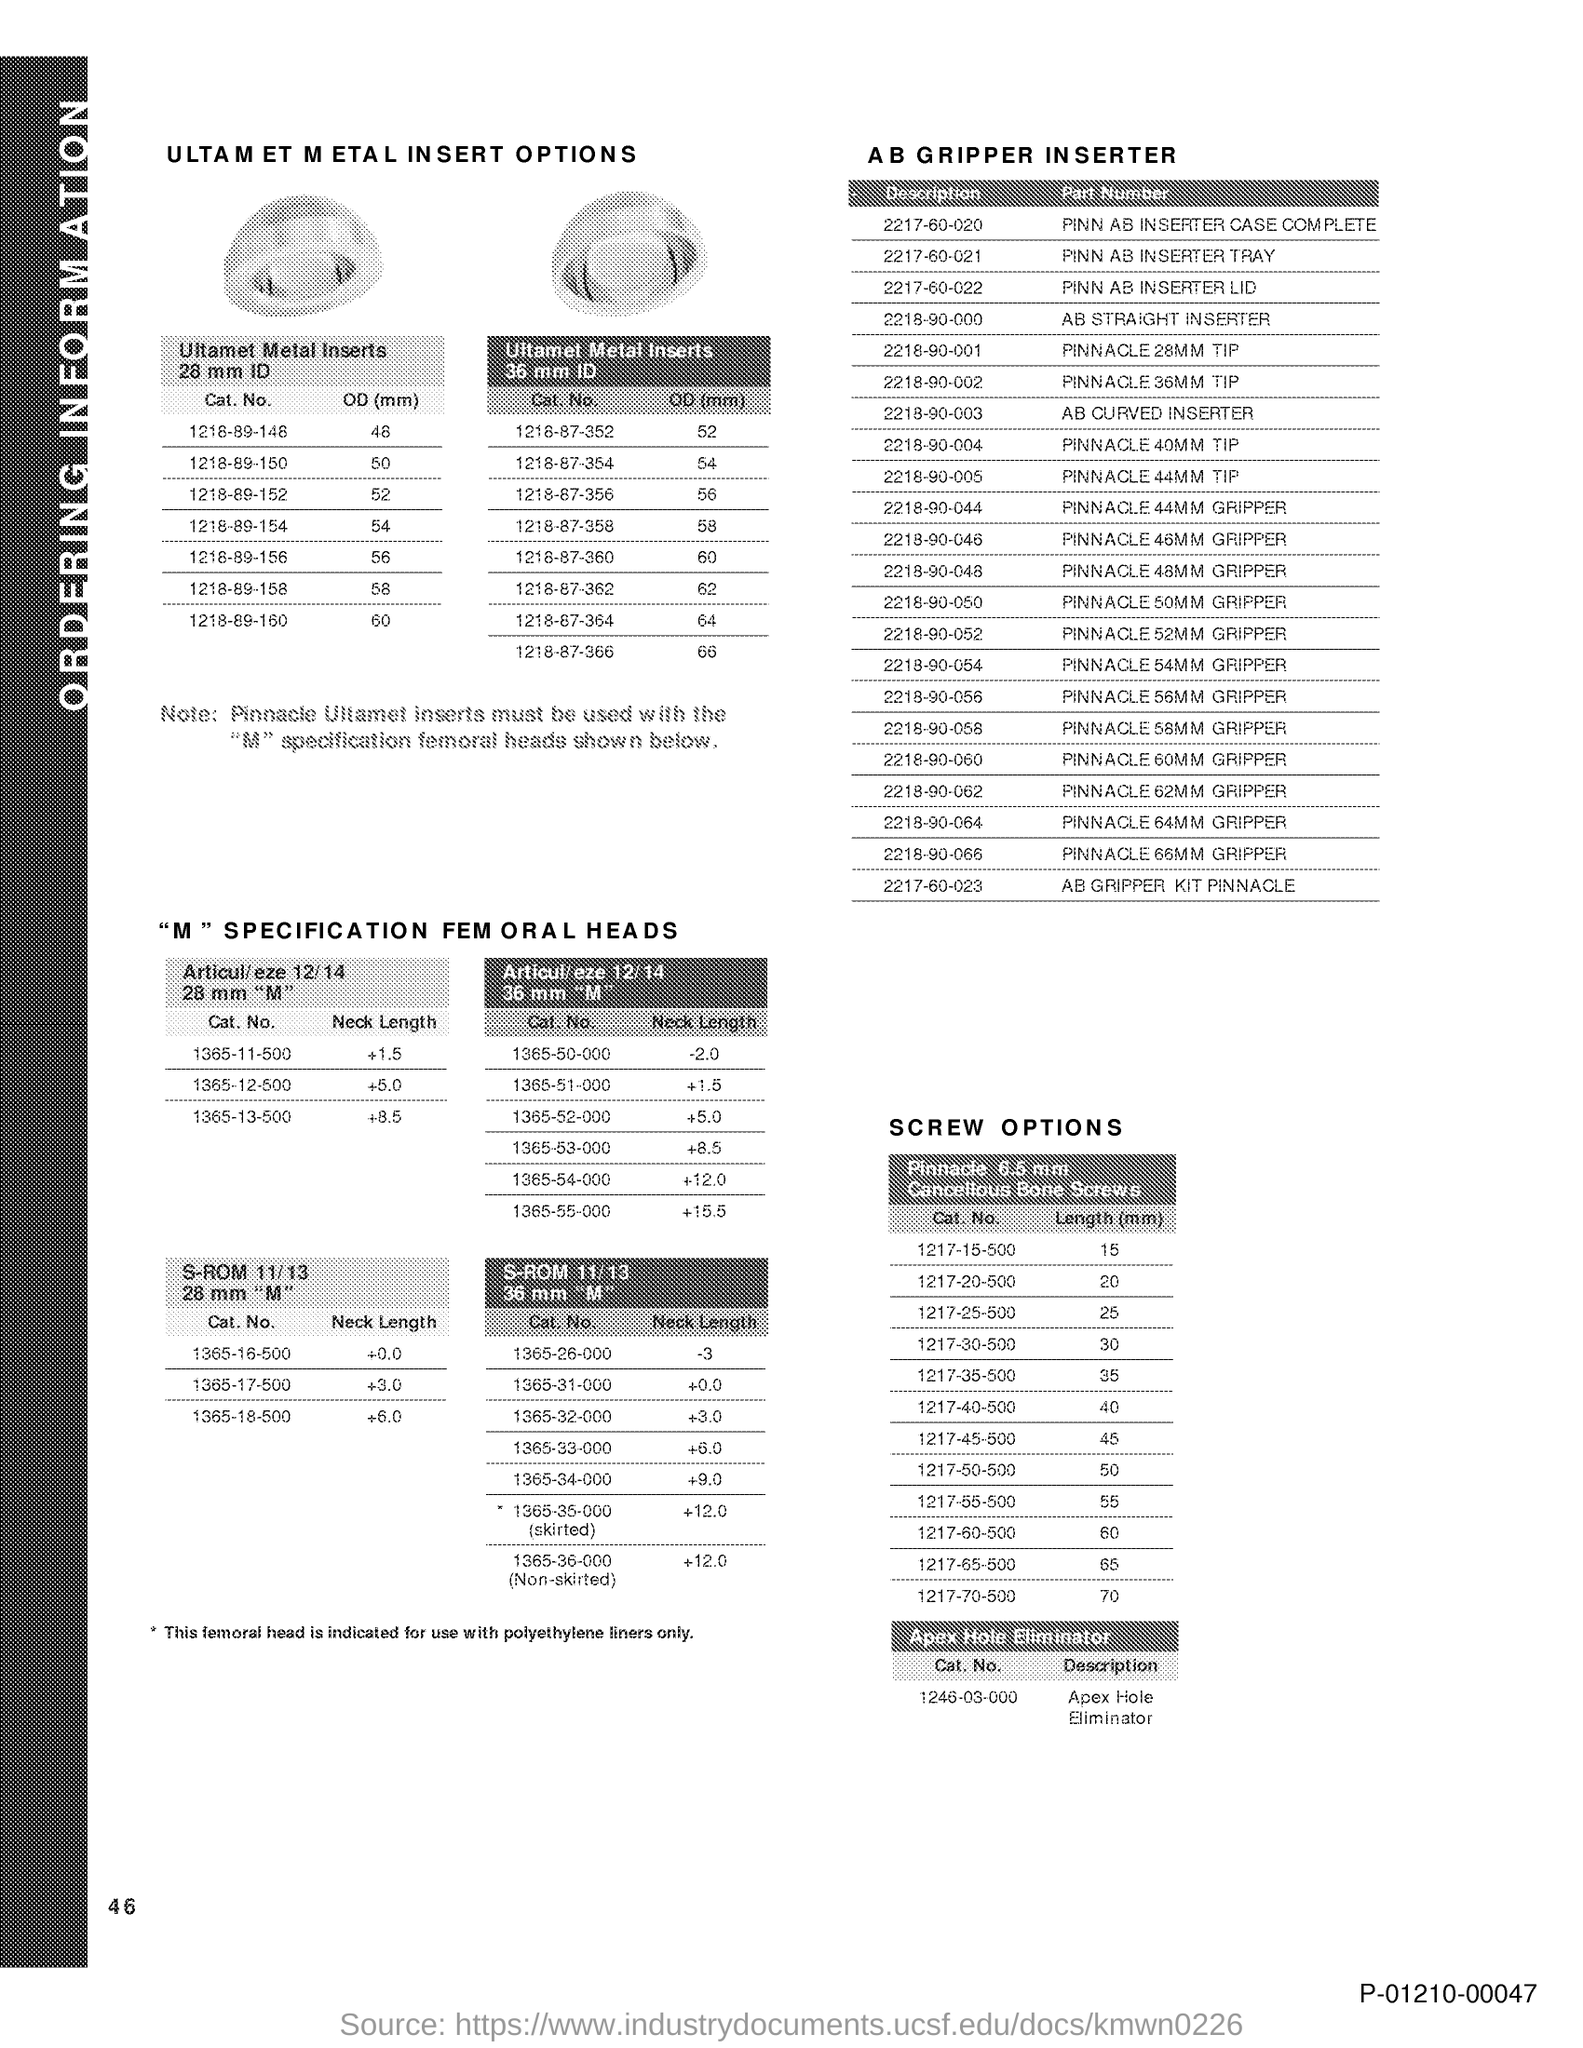Point out several critical features in this image. The length in millimeters for Cat. no. 1217-30-500 is 30.. The length in millimeters for Cat. no. 1217-40-500 is 40.. The length of Cat. No. 1217-50-500 is 50 mm. The length in millimeters for Cat. No. 1217-60-500 is 60.. The length of Cat. no. 1217-20-500 is [objective]. 